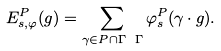Convert formula to latex. <formula><loc_0><loc_0><loc_500><loc_500>E ^ { P } _ { s , \varphi } ( g ) = \sum _ { \gamma \in P \cap \Gamma \ \Gamma } \varphi ^ { P } _ { s } ( \gamma \cdot g ) .</formula> 